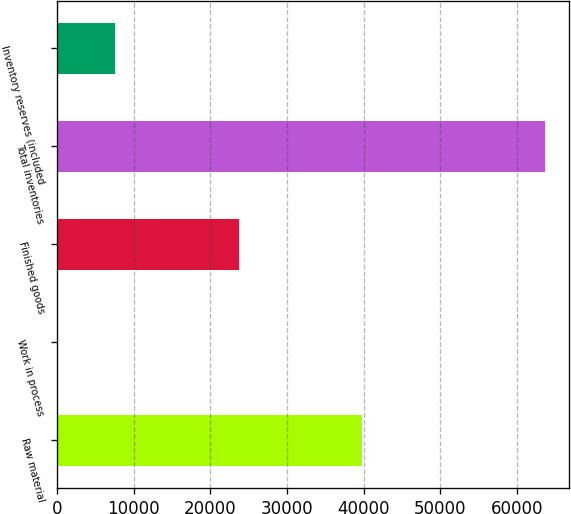<chart> <loc_0><loc_0><loc_500><loc_500><bar_chart><fcel>Raw material<fcel>Work in process<fcel>Finished goods<fcel>Total inventories<fcel>Inventory reserves (included<nl><fcel>39779<fcel>134<fcel>23725<fcel>63638<fcel>7598<nl></chart> 